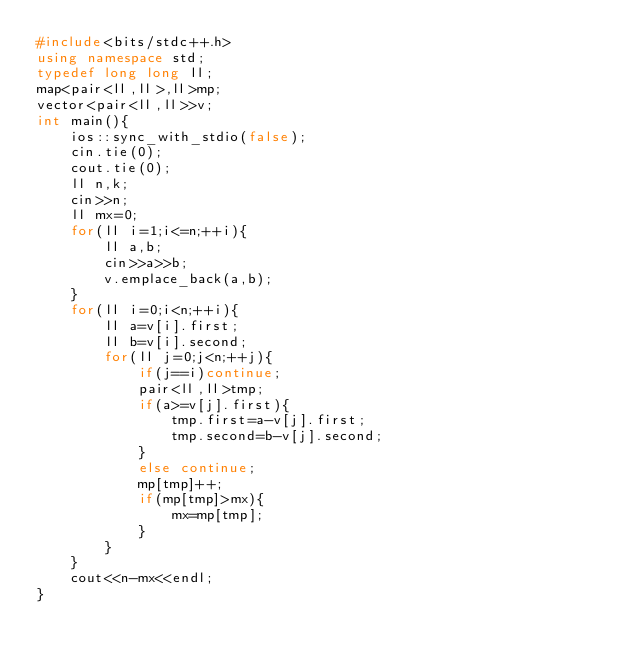Convert code to text. <code><loc_0><loc_0><loc_500><loc_500><_C++_>#include<bits/stdc++.h>
using namespace std;
typedef long long ll;
map<pair<ll,ll>,ll>mp;
vector<pair<ll,ll>>v;
int main(){
    ios::sync_with_stdio(false);
    cin.tie(0);
    cout.tie(0);
    ll n,k;
    cin>>n;
    ll mx=0;
    for(ll i=1;i<=n;++i){
        ll a,b;
        cin>>a>>b;
        v.emplace_back(a,b);
    }
    for(ll i=0;i<n;++i){
        ll a=v[i].first;
        ll b=v[i].second;
        for(ll j=0;j<n;++j){
            if(j==i)continue;
            pair<ll,ll>tmp;
            if(a>=v[j].first){
                tmp.first=a-v[j].first;
                tmp.second=b-v[j].second;
            }
            else continue;
            mp[tmp]++;
            if(mp[tmp]>mx){
                mx=mp[tmp];
            }
        }
    }
    cout<<n-mx<<endl;
}
</code> 